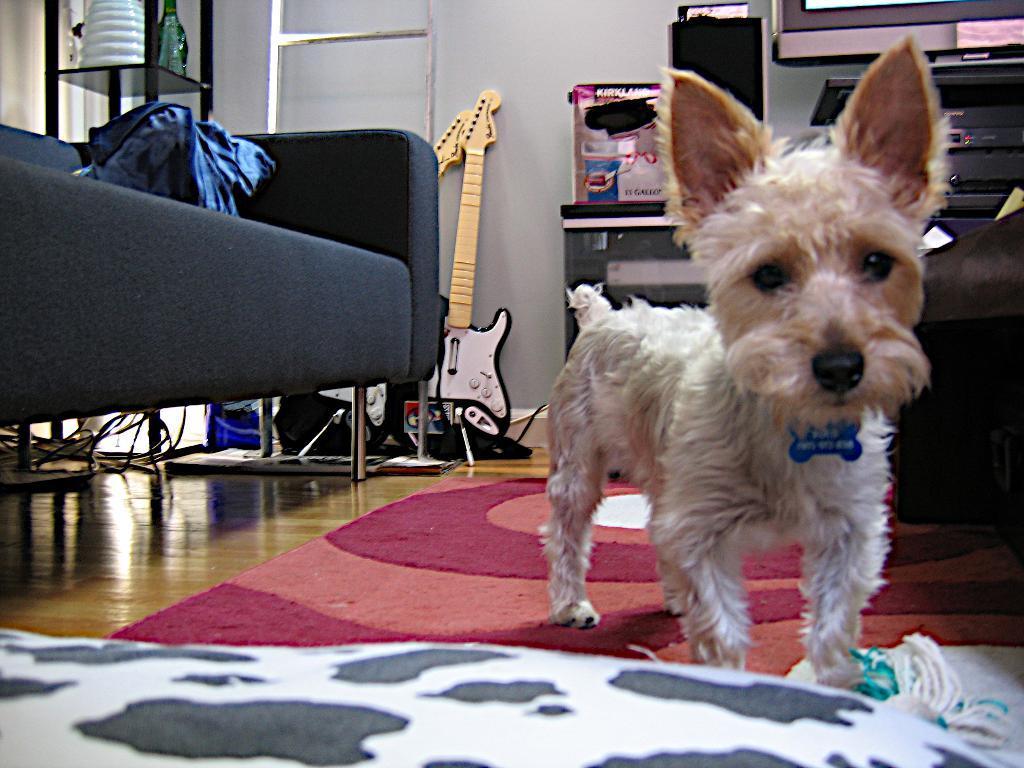How would you summarize this image in a sentence or two? This is the picture inside of the room. At the left side of the image there is sofa. In the middle there is a dog standing on the mat. At the back there is a guitar and a stand and at the right there is a device. 